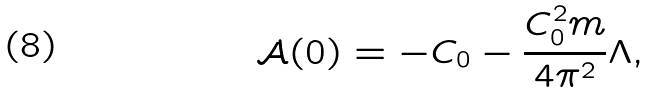Convert formula to latex. <formula><loc_0><loc_0><loc_500><loc_500>\mathcal { A } ( 0 ) = - C _ { 0 } - \frac { C _ { 0 } ^ { 2 } m } { 4 \pi ^ { 2 } } \Lambda ,</formula> 